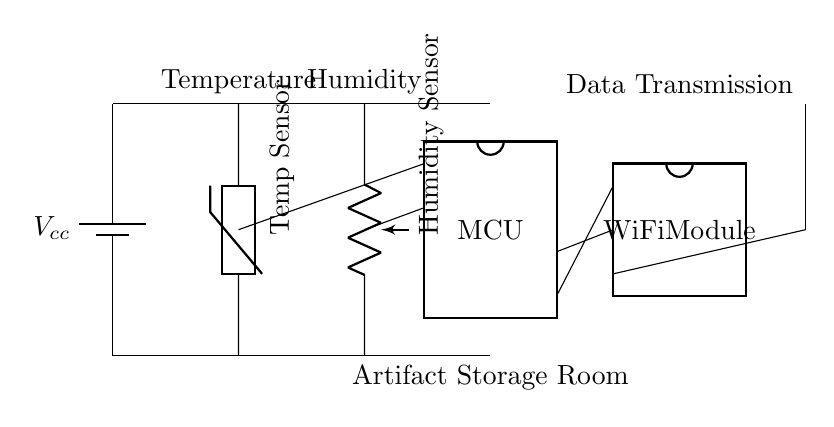What components are included in the circuit? The components are a battery, temperature sensor, humidity sensor, microcontroller, WiFi module, and an antenna. Each of these components is clearly labeled in the diagram, allowing for easy identification.
Answer: Battery, temperature sensor, humidity sensor, microcontroller, WiFi module, antenna What type of sensors are used in the circuit? The sensors used are a thermistor for temperature and a potentiometer for humidity. These types of sensors are specifically designed for measuring their respective environmental factors, and their labels confirm this information.
Answer: Thermistor, potentiometer How many pins does the microcontroller have? The microcontroller is shown to have eight pins, as indicated by the number of external pins depicted in the dipchip symbol within the circuit diagram.
Answer: Eight What is the purpose of the WiFi module in the circuit? The purpose of the WiFi module is to facilitate data transmission, as inferred from its connection to the microcontroller and the label indicating "Data Transmission." This allows for remote monitoring of temperature and humidity data.
Answer: Data Transmission How is the temperature sensor connected to the microcontroller? The temperature sensor is connected to pin one of the microcontroller, which is indicated by the line drawn from the middle of the sensor, directly connecting it to the specific pin. This connection allows the sensor to send temperature readings to the microcontroller for processing.
Answer: Pin one What is the voltage source labeled in the circuit? The voltage source is labeled as Vcc, which typically indicates the primary supply voltage for powering the circuit components. Its position at the top of the circuit indicates it is a battery providing the necessary voltage for operation.
Answer: Vcc 